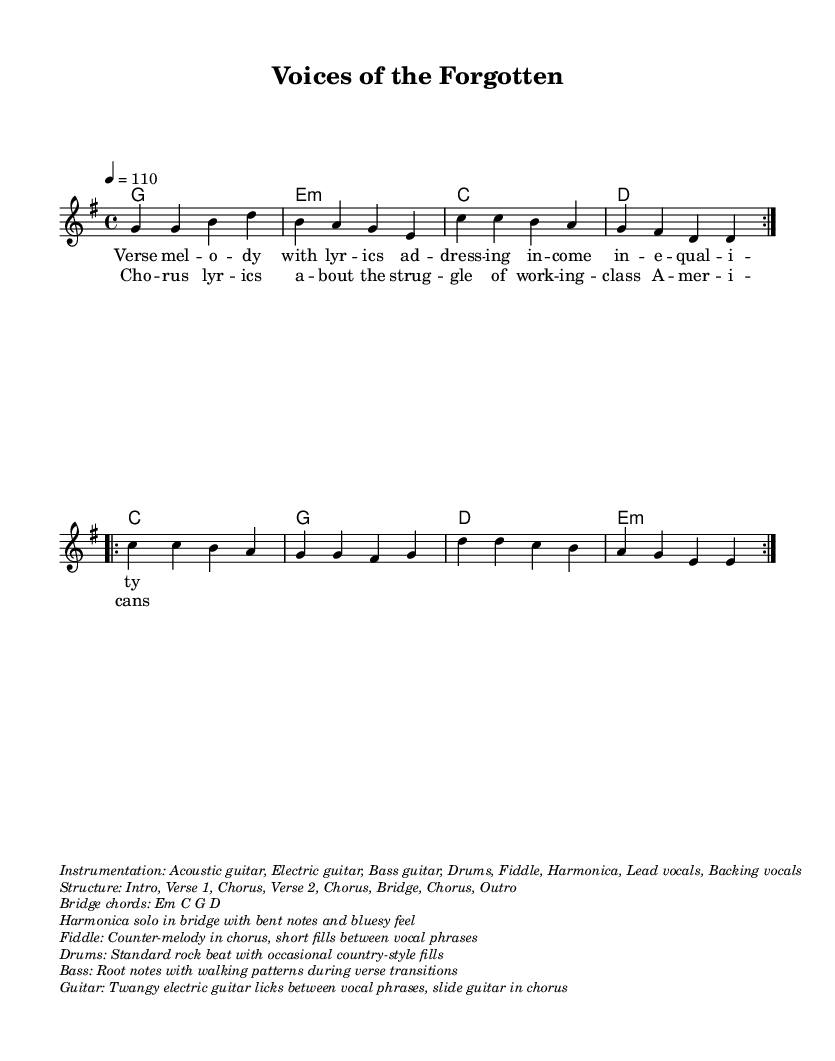What is the key signature of this music? The key signature is G major, which has one sharp (F#). This can be identified by the key signature indicated at the beginning of the score.
Answer: G major What is the time signature of this music? The time signature is 4/4, which is specified at the beginning of the score. This means there are four beats in each measure, and the quarter note gets one beat.
Answer: 4/4 What is the tempo marking of this music? The tempo marking indicates a speed of 110 BPM (beats per minute). This is noted in the tempo section of the music which shows "4 = 110".
Answer: 110 How many verses are in the structure of the song? The structure indicates there are two verses, as noted in the song's layout where it lists "Verse 1" and "Verse 2".
Answer: 2 What is the instrumentation specified for this music? The instrumentation includes several instruments, specifically Acoustic guitar, Electric guitar, Bass guitar, Drums, Fiddle, Harmonica, Lead vocals, and Backing vocals. This is specified in the markup section.
Answer: Acoustic guitar, Electric guitar, Bass guitar, Drums, Fiddle, Harmonica, Lead vocals, Backing vocals What does the bridge consist of? The bridge consists of the chords Em, C, G, and D. This is clearly outlined in the additional markup section that lists "Bridge chords: Em C G D".
Answer: Em C G D What is the thematic focus of the lyrics in this song? The thematic focus of the lyrics addresses income inequality and the struggles of working-class Americans, as indicated in the lyrics section and the title "Voices of the Forgotten".
Answer: Income inequality and working-class struggles 